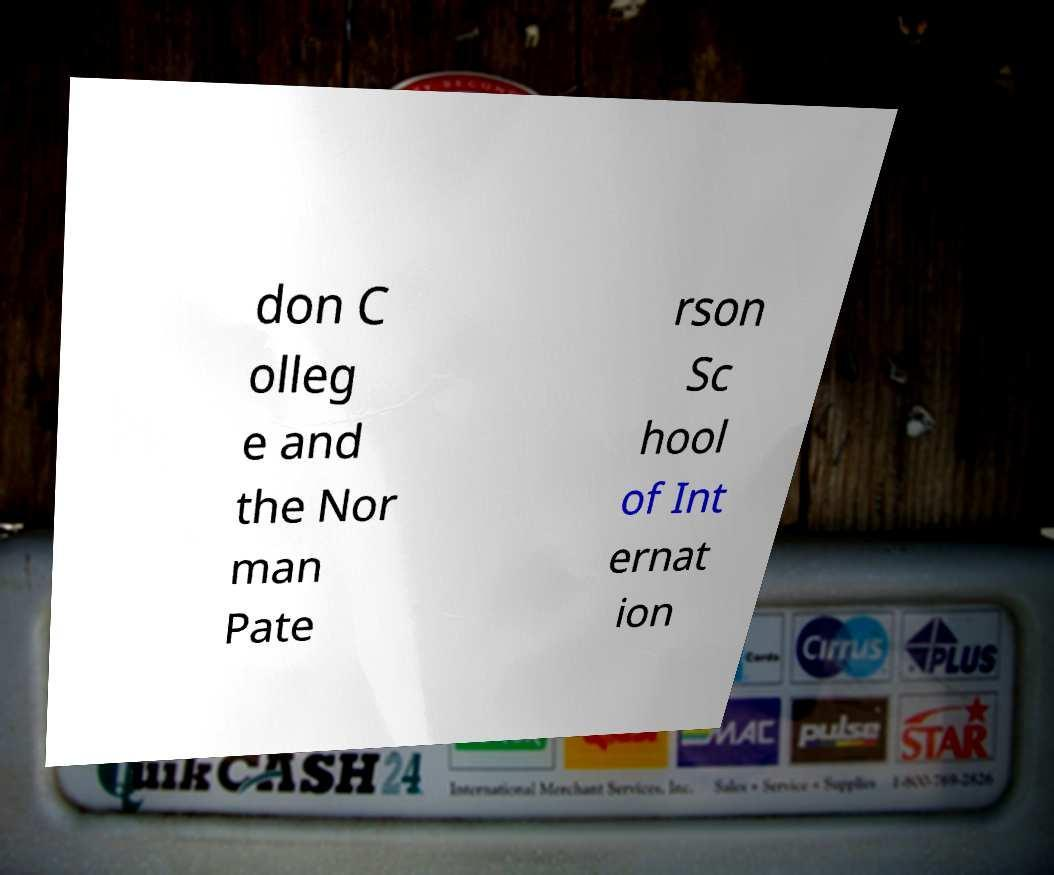Could you assist in decoding the text presented in this image and type it out clearly? don C olleg e and the Nor man Pate rson Sc hool of Int ernat ion 